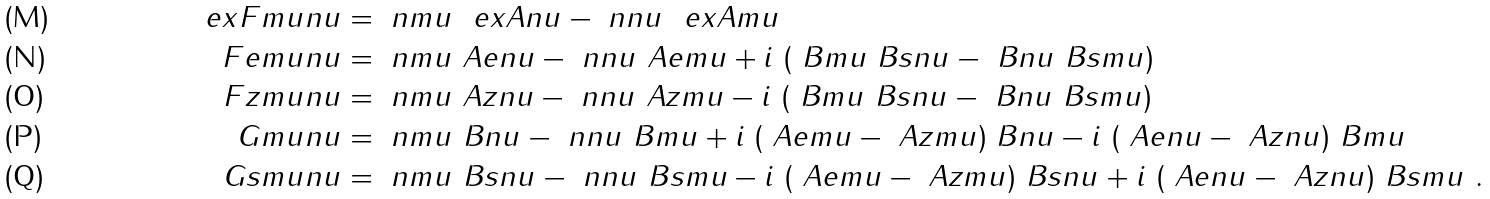Convert formula to latex. <formula><loc_0><loc_0><loc_500><loc_500>\ e x F m u n u & = \ n m u \ \ e x A n u - \ n n u \ \ e x A m u \\ \ F e m u n u & = \ n m u \ A e n u - \ n n u \ A e m u + i \ ( \ B m u \ B s n u - \ B n u \ B s m u ) \\ \ F z m u n u & = \ n m u \ A z n u - \ n n u \ A z m u - i \ ( \ B m u \ B s n u - \ B n u \ B s m u ) \\ \ G m u n u & = \ n m u \ B n u - \ n n u \ B m u + i \ ( \ A e m u - \ A z m u ) \ B n u - i \ ( \ A e n u - \ A z n u ) \ B m u \\ \ G s m u n u & = \ n m u \ B s n u - \ n n u \ B s m u - i \ ( \ A e m u - \ A z m u ) \ B s n u + i \ ( \ A e n u - \ A z n u ) \ B s m u \ .</formula> 